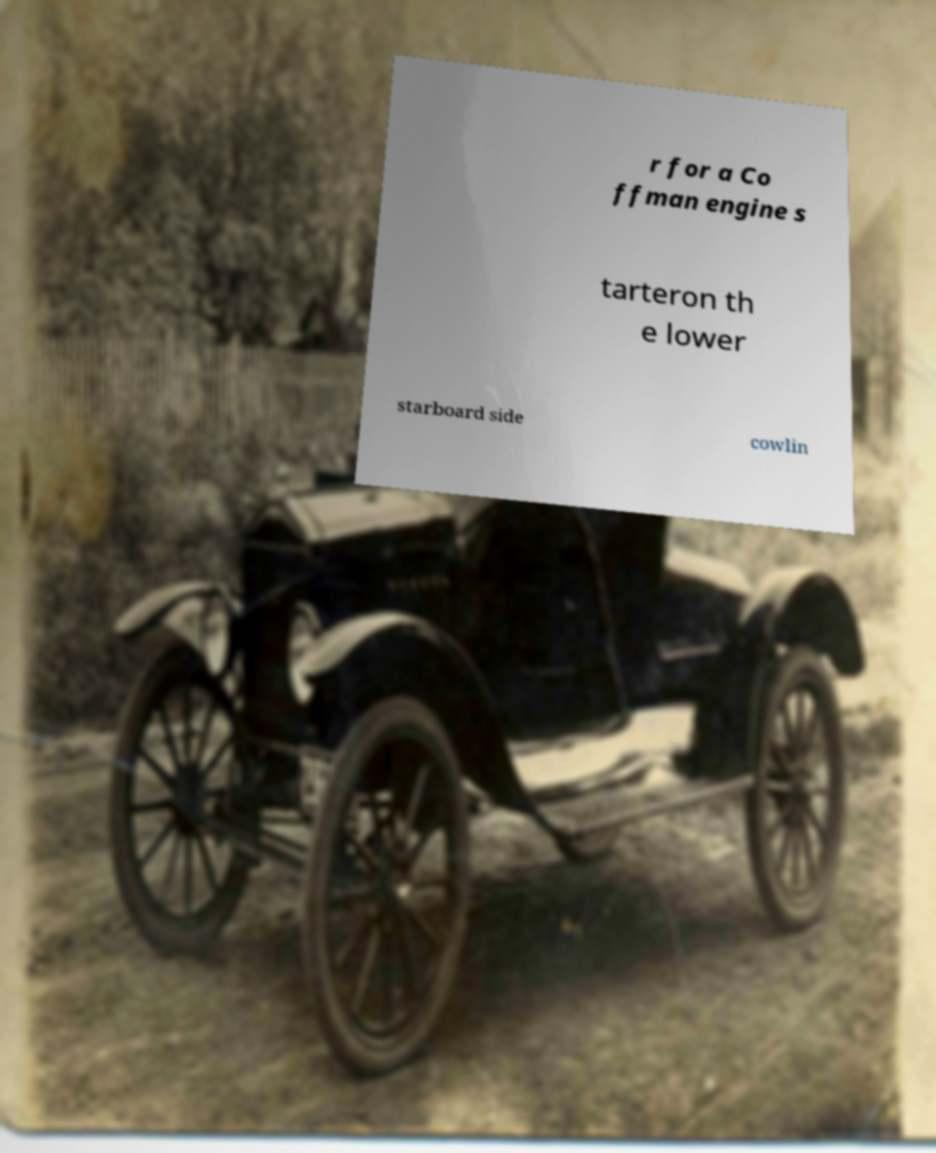Can you accurately transcribe the text from the provided image for me? r for a Co ffman engine s tarteron th e lower starboard side cowlin 